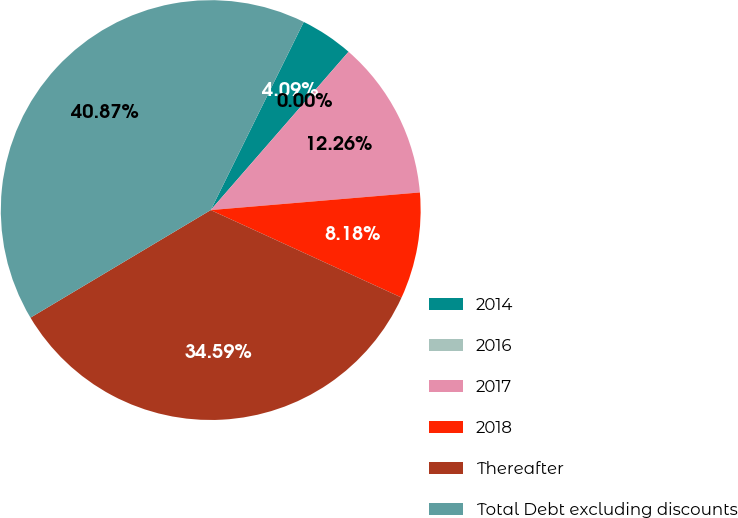Convert chart to OTSL. <chart><loc_0><loc_0><loc_500><loc_500><pie_chart><fcel>2014<fcel>2016<fcel>2017<fcel>2018<fcel>Thereafter<fcel>Total Debt excluding discounts<nl><fcel>4.09%<fcel>0.0%<fcel>12.26%<fcel>8.18%<fcel>34.59%<fcel>40.87%<nl></chart> 